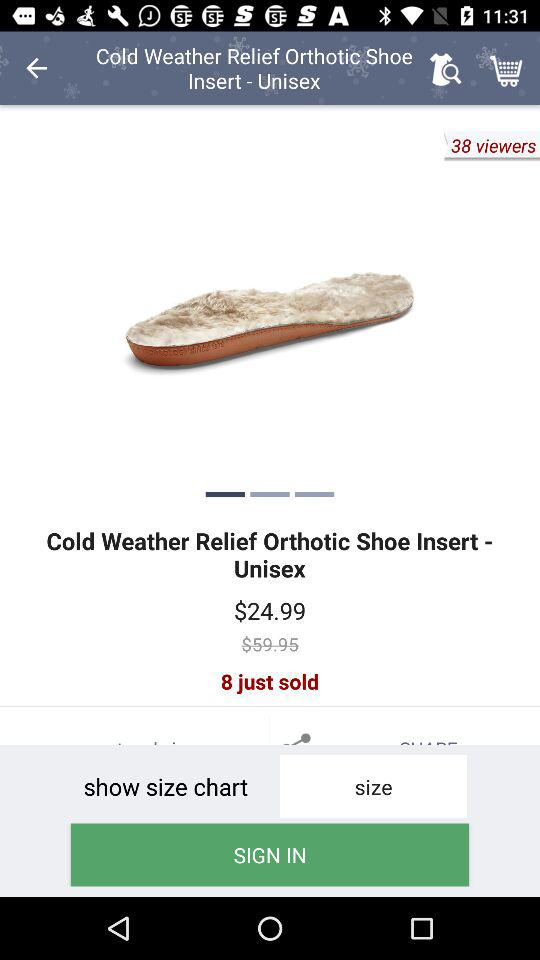What is the price of the Cold Weather Relief Orthotic Shoe Insert - Unisex?
Answer the question using a single word or phrase. $24.99 